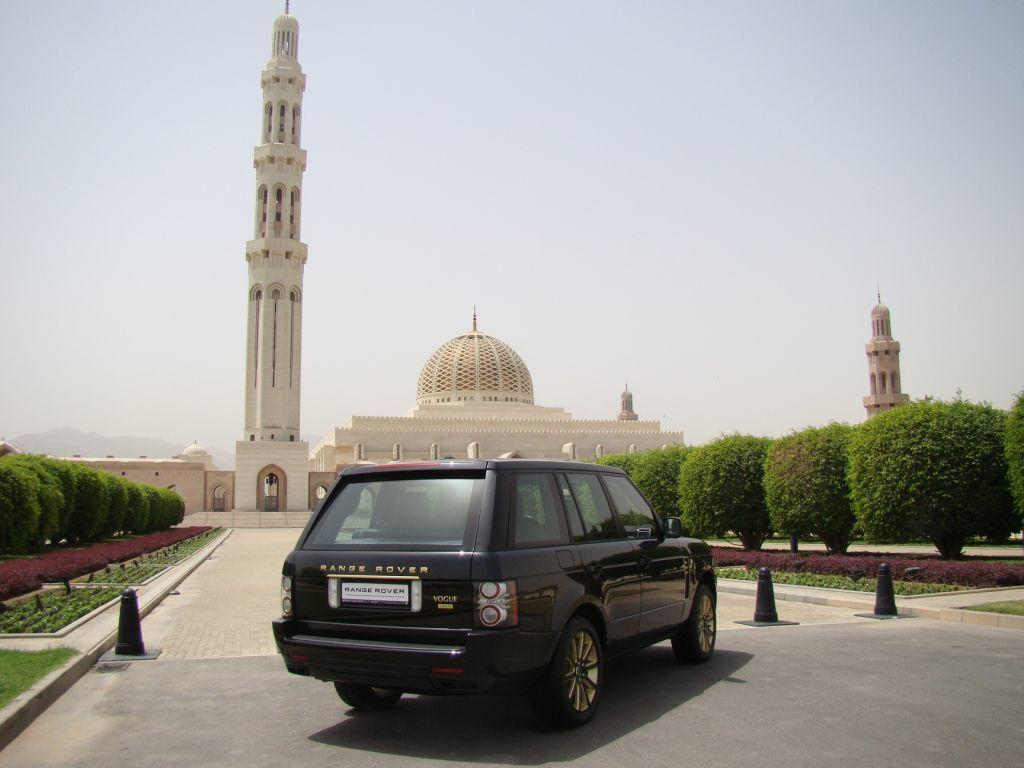<image>
Offer a succinct explanation of the picture presented. a Range Rover that is outside near monuments 